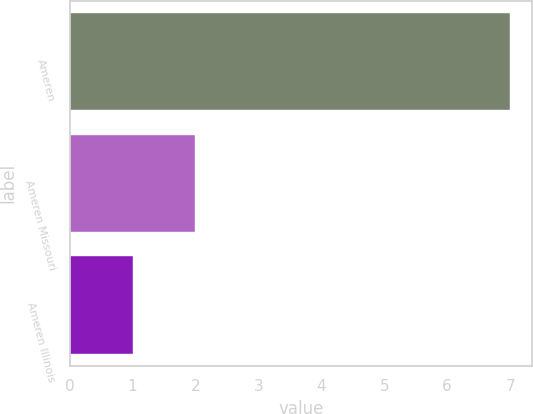<chart> <loc_0><loc_0><loc_500><loc_500><bar_chart><fcel>Ameren<fcel>Ameren Missouri<fcel>Ameren Illinois<nl><fcel>7<fcel>2<fcel>1<nl></chart> 